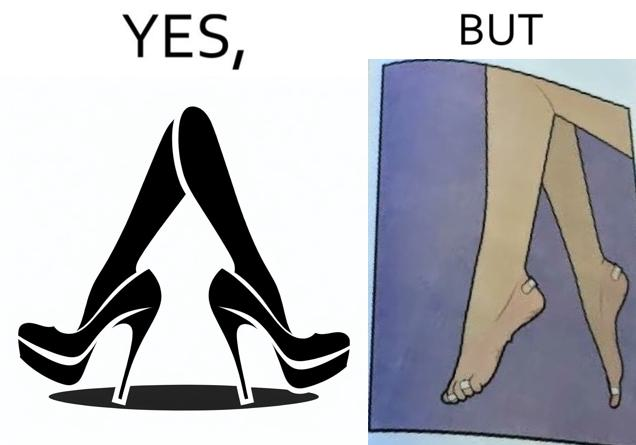What is shown in this image? The images are funny since they show how the prettiest footwears like high heels, end up causing a lot of physical discomfort to the user, all in the name fashion 